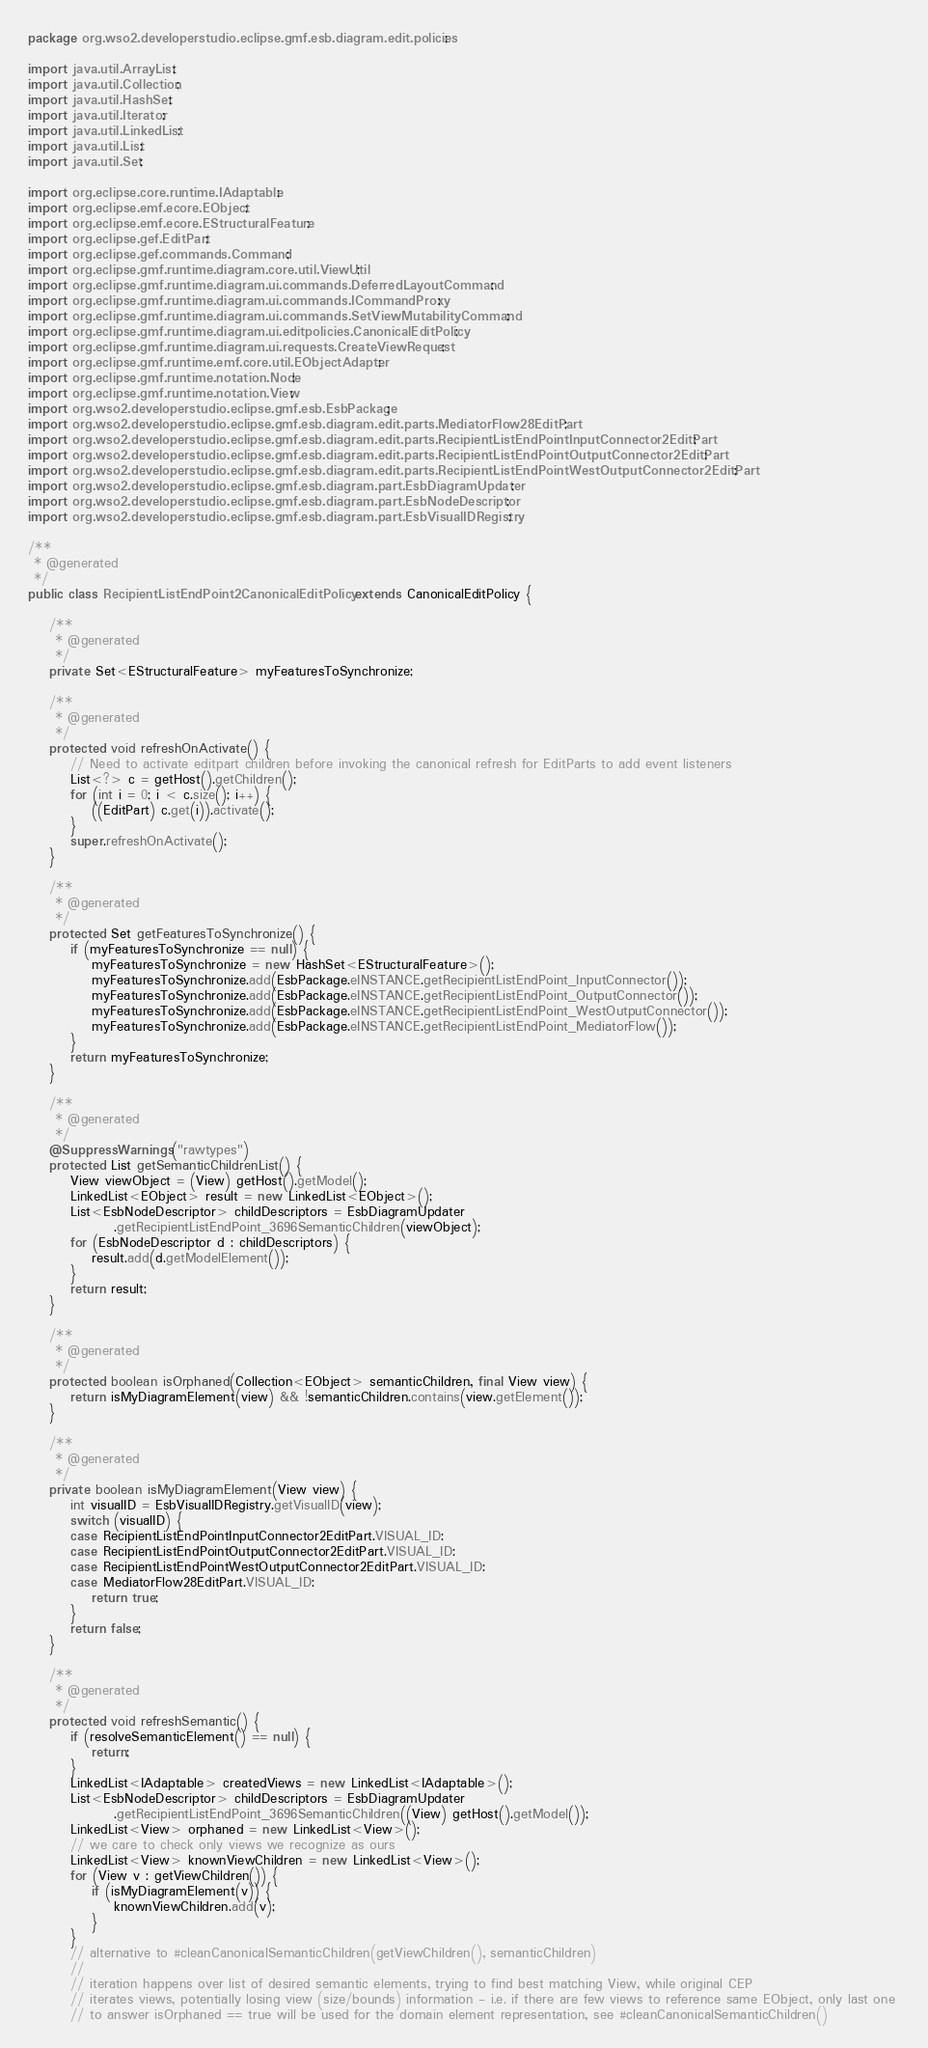<code> <loc_0><loc_0><loc_500><loc_500><_Java_>package org.wso2.developerstudio.eclipse.gmf.esb.diagram.edit.policies;

import java.util.ArrayList;
import java.util.Collection;
import java.util.HashSet;
import java.util.Iterator;
import java.util.LinkedList;
import java.util.List;
import java.util.Set;

import org.eclipse.core.runtime.IAdaptable;
import org.eclipse.emf.ecore.EObject;
import org.eclipse.emf.ecore.EStructuralFeature;
import org.eclipse.gef.EditPart;
import org.eclipse.gef.commands.Command;
import org.eclipse.gmf.runtime.diagram.core.util.ViewUtil;
import org.eclipse.gmf.runtime.diagram.ui.commands.DeferredLayoutCommand;
import org.eclipse.gmf.runtime.diagram.ui.commands.ICommandProxy;
import org.eclipse.gmf.runtime.diagram.ui.commands.SetViewMutabilityCommand;
import org.eclipse.gmf.runtime.diagram.ui.editpolicies.CanonicalEditPolicy;
import org.eclipse.gmf.runtime.diagram.ui.requests.CreateViewRequest;
import org.eclipse.gmf.runtime.emf.core.util.EObjectAdapter;
import org.eclipse.gmf.runtime.notation.Node;
import org.eclipse.gmf.runtime.notation.View;
import org.wso2.developerstudio.eclipse.gmf.esb.EsbPackage;
import org.wso2.developerstudio.eclipse.gmf.esb.diagram.edit.parts.MediatorFlow28EditPart;
import org.wso2.developerstudio.eclipse.gmf.esb.diagram.edit.parts.RecipientListEndPointInputConnector2EditPart;
import org.wso2.developerstudio.eclipse.gmf.esb.diagram.edit.parts.RecipientListEndPointOutputConnector2EditPart;
import org.wso2.developerstudio.eclipse.gmf.esb.diagram.edit.parts.RecipientListEndPointWestOutputConnector2EditPart;
import org.wso2.developerstudio.eclipse.gmf.esb.diagram.part.EsbDiagramUpdater;
import org.wso2.developerstudio.eclipse.gmf.esb.diagram.part.EsbNodeDescriptor;
import org.wso2.developerstudio.eclipse.gmf.esb.diagram.part.EsbVisualIDRegistry;

/**
 * @generated
 */
public class RecipientListEndPoint2CanonicalEditPolicy extends CanonicalEditPolicy {

    /**
     * @generated
     */
    private Set<EStructuralFeature> myFeaturesToSynchronize;

    /**
     * @generated
     */
    protected void refreshOnActivate() {
        // Need to activate editpart children before invoking the canonical refresh for EditParts to add event listeners
        List<?> c = getHost().getChildren();
        for (int i = 0; i < c.size(); i++) {
            ((EditPart) c.get(i)).activate();
        }
        super.refreshOnActivate();
    }

    /**
     * @generated
     */
    protected Set getFeaturesToSynchronize() {
        if (myFeaturesToSynchronize == null) {
            myFeaturesToSynchronize = new HashSet<EStructuralFeature>();
            myFeaturesToSynchronize.add(EsbPackage.eINSTANCE.getRecipientListEndPoint_InputConnector());
            myFeaturesToSynchronize.add(EsbPackage.eINSTANCE.getRecipientListEndPoint_OutputConnector());
            myFeaturesToSynchronize.add(EsbPackage.eINSTANCE.getRecipientListEndPoint_WestOutputConnector());
            myFeaturesToSynchronize.add(EsbPackage.eINSTANCE.getRecipientListEndPoint_MediatorFlow());
        }
        return myFeaturesToSynchronize;
    }

    /**
     * @generated
     */
    @SuppressWarnings("rawtypes")
    protected List getSemanticChildrenList() {
        View viewObject = (View) getHost().getModel();
        LinkedList<EObject> result = new LinkedList<EObject>();
        List<EsbNodeDescriptor> childDescriptors = EsbDiagramUpdater
                .getRecipientListEndPoint_3696SemanticChildren(viewObject);
        for (EsbNodeDescriptor d : childDescriptors) {
            result.add(d.getModelElement());
        }
        return result;
    }

    /**
     * @generated
     */
    protected boolean isOrphaned(Collection<EObject> semanticChildren, final View view) {
        return isMyDiagramElement(view) && !semanticChildren.contains(view.getElement());
    }

    /**
     * @generated
     */
    private boolean isMyDiagramElement(View view) {
        int visualID = EsbVisualIDRegistry.getVisualID(view);
        switch (visualID) {
        case RecipientListEndPointInputConnector2EditPart.VISUAL_ID:
        case RecipientListEndPointOutputConnector2EditPart.VISUAL_ID:
        case RecipientListEndPointWestOutputConnector2EditPart.VISUAL_ID:
        case MediatorFlow28EditPart.VISUAL_ID:
            return true;
        }
        return false;
    }

    /**
     * @generated
     */
    protected void refreshSemantic() {
        if (resolveSemanticElement() == null) {
            return;
        }
        LinkedList<IAdaptable> createdViews = new LinkedList<IAdaptable>();
        List<EsbNodeDescriptor> childDescriptors = EsbDiagramUpdater
                .getRecipientListEndPoint_3696SemanticChildren((View) getHost().getModel());
        LinkedList<View> orphaned = new LinkedList<View>();
        // we care to check only views we recognize as ours
        LinkedList<View> knownViewChildren = new LinkedList<View>();
        for (View v : getViewChildren()) {
            if (isMyDiagramElement(v)) {
                knownViewChildren.add(v);
            }
        }
        // alternative to #cleanCanonicalSemanticChildren(getViewChildren(), semanticChildren)
        //
        // iteration happens over list of desired semantic elements, trying to find best matching View, while original CEP
        // iterates views, potentially losing view (size/bounds) information - i.e. if there are few views to reference same EObject, only last one 
        // to answer isOrphaned == true will be used for the domain element representation, see #cleanCanonicalSemanticChildren()</code> 